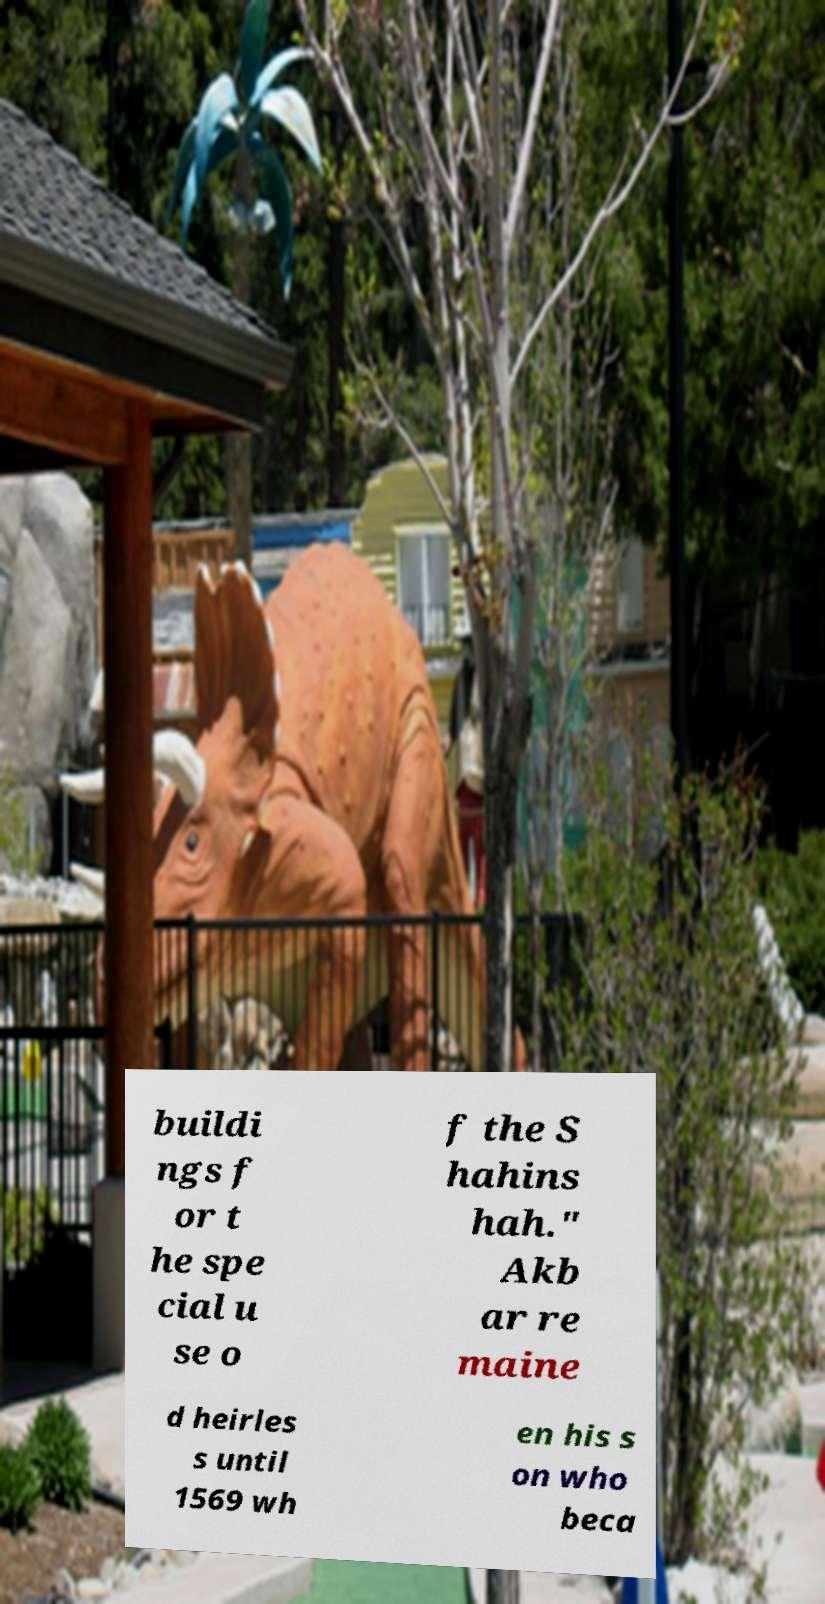Please identify and transcribe the text found in this image. buildi ngs f or t he spe cial u se o f the S hahins hah." Akb ar re maine d heirles s until 1569 wh en his s on who beca 